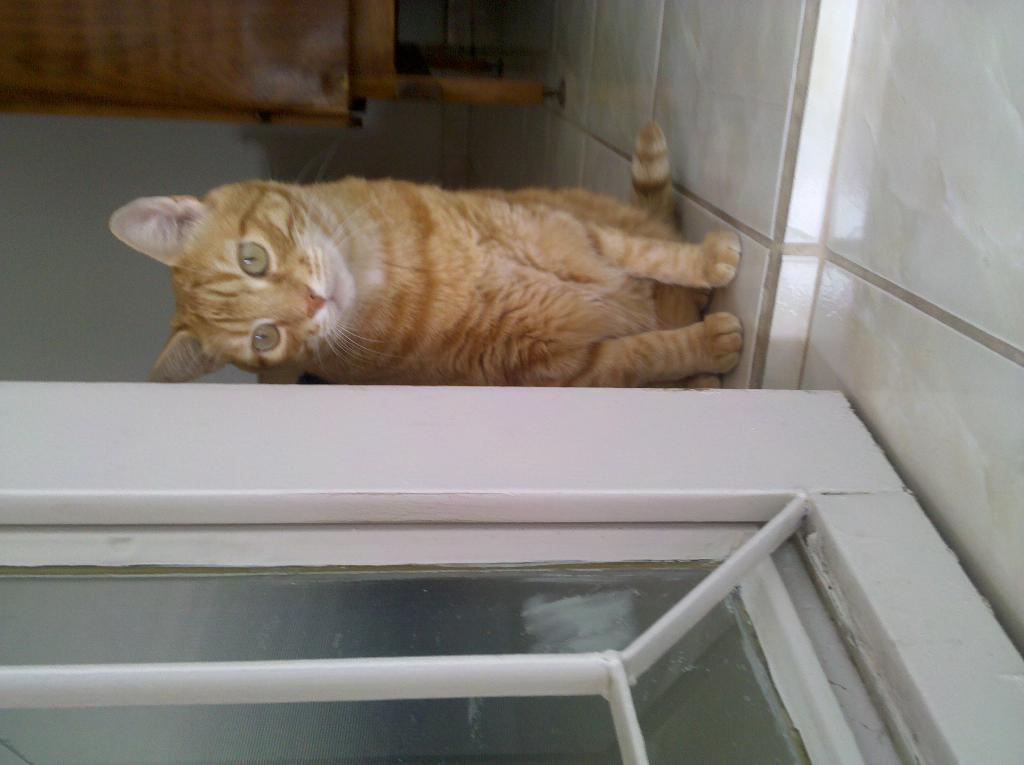Can you describe this image briefly? In this image, we can see a cat is sitting on the floor. At the bottom, we can see a glass door and grill. Background there is a wall and wooden piece. 